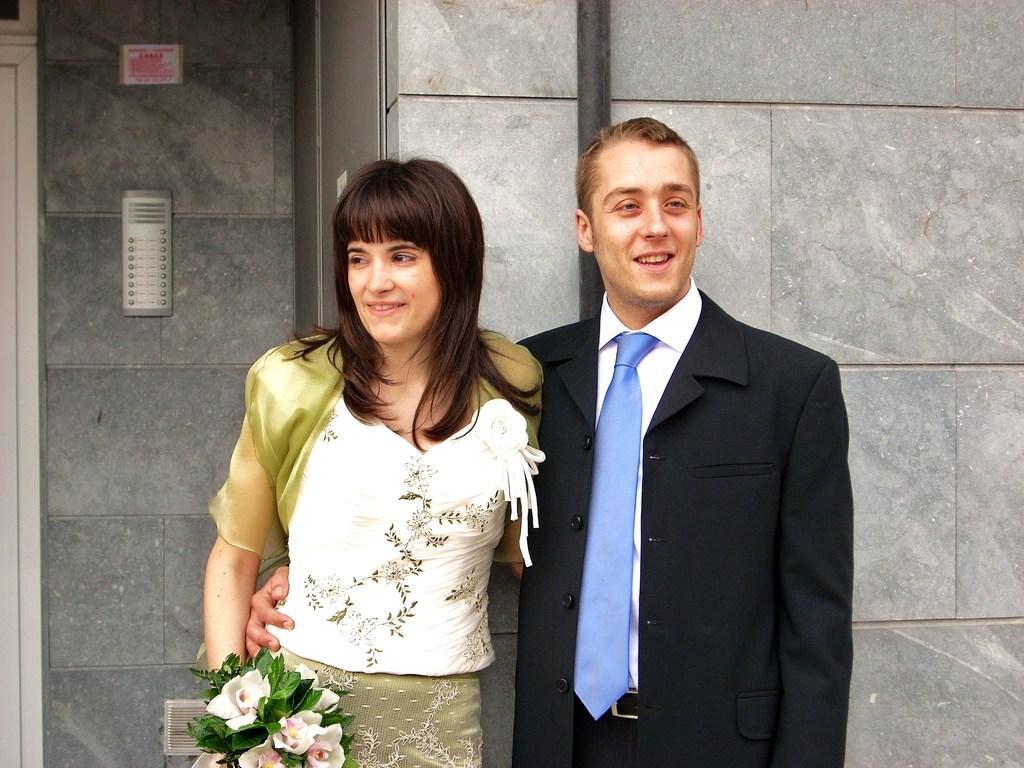Please provide a concise description of this image. In this image, we can see a woman and man are smiling. At the bottom, we can see a flower bouquet. Background there is a wall, rod, doors, some object, poster. 